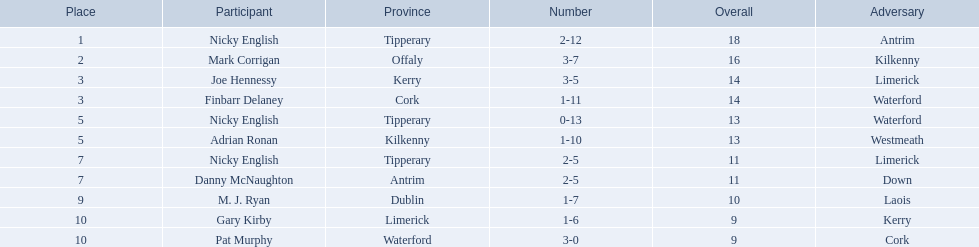Which of the following players were ranked in the bottom 5? Nicky English, Danny McNaughton, M. J. Ryan, Gary Kirby, Pat Murphy. Of these, whose tallies were not 2-5? M. J. Ryan, Gary Kirby, Pat Murphy. From the above three, which one scored more than 9 total points? M. J. Ryan. 